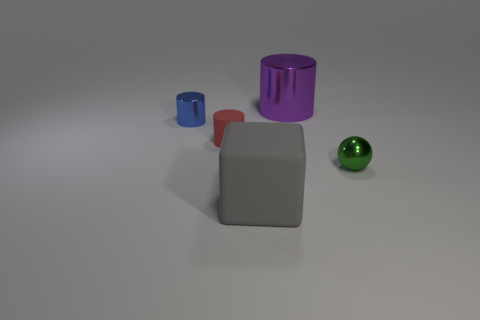Add 4 rubber things. How many objects exist? 9 Subtract 1 cylinders. How many cylinders are left? 2 Subtract all blue metallic cylinders. How many cylinders are left? 2 Subtract all cylinders. How many objects are left? 2 Subtract all cyan metal objects. Subtract all gray blocks. How many objects are left? 4 Add 3 shiny balls. How many shiny balls are left? 4 Add 2 big gray rubber cylinders. How many big gray rubber cylinders exist? 2 Subtract all blue cylinders. How many cylinders are left? 2 Subtract 0 purple cubes. How many objects are left? 5 Subtract all yellow spheres. Subtract all green cubes. How many spheres are left? 1 